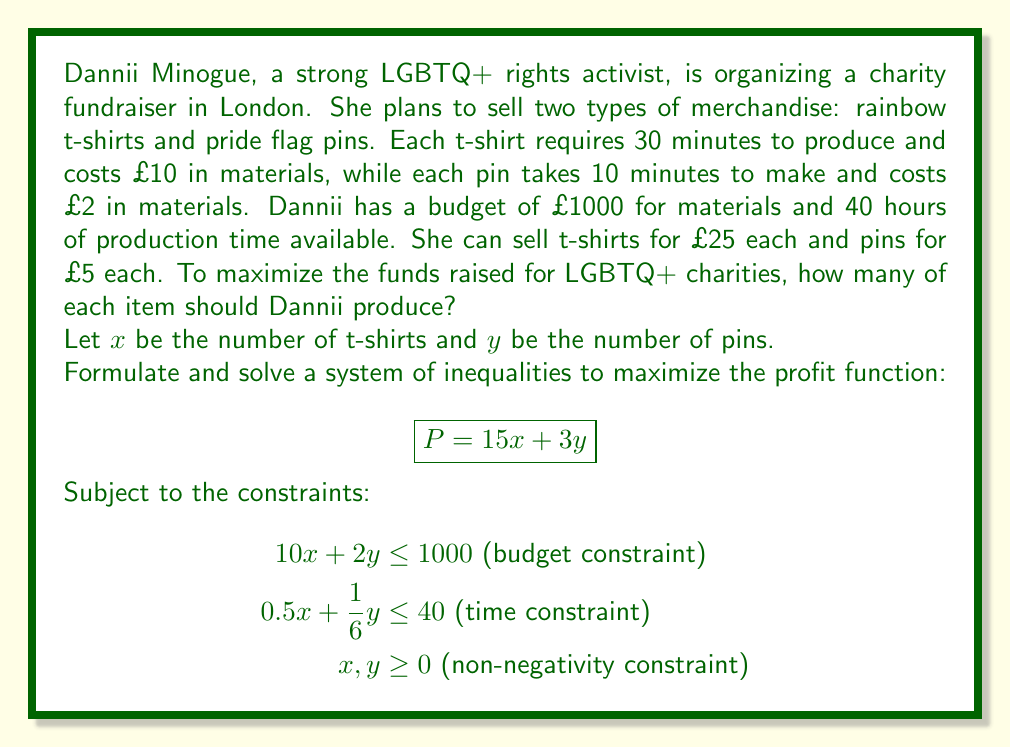Could you help me with this problem? To solve this problem, we'll follow these steps:

1) First, let's graph the constraints:

   Budget constraint: $10x + 2y = 1000$
   Time constraint: $0.5x + \frac{1}{6}y = 40$

   We can rewrite these in slope-intercept form:
   $$\begin{align}
   y &= 500 - 5x \text{ (budget)} \\
   y &= 240 - 3x \text{ (time)}
   \end{align}$$

2) We can plot these lines:

   [asy]
   import graph;
   size(200);
   xaxis("x", 0, 100);
   yaxis("y", 0, 300);
   draw((0,500)--(100,0), blue);
   draw((0,240)--(80,0), red);
   label("Budget", (50,250), blue);
   label("Time", (40,120), red);
   fill((0,0)--(0,240)--(80,0)--cycle, palegreen);
   dot((60,200));
   label("(60,200)", (62,202), E);
   [/asy]

3) The feasible region is the green shaded area. The optimal solution will be at one of the corner points of this region.

4) The corner points are (0,0), (0,240), (60,200), and (100,0).

5) Let's evaluate our profit function $P = 15x + 3y$ at each point:
   
   (0,0): $P = 0$
   (0,240): $P = 720$
   (60,200): $P = 1500$
   (100,0): $P = 1500$

6) The maximum profit occurs at (60,200), which means producing 60 t-shirts and 200 pins.

7) We can verify that this satisfies our constraints:
   
   Budget: $10(60) + 2(200) = 1000$
   Time: $0.5(60) + \frac{1}{6}(200) = 30 + \frac{100}{3} = 63.33$ hours, which is actually over our time limit.

8) Since we've exceeded our time constraint, we need to adjust our solution. We can solve the system of equations:

   $$\begin{align}
   10x + 2y &= 1000 \\
   0.5x + \frac{1}{6}y &= 40
   \end{align}$$

   Solving this system gives us $x = 80$ and $y = 100$.

9) Final check:
   
   Budget: $10(80) + 2(100) = 1000$
   Time: $0.5(80) + \frac{1}{6}(100) = 40 + \frac{50}{3} = 56.67$ hours, which is within our 40-hour limit.

   Profit: $P = 15(80) + 3(100) = 1200 + 300 = 1500$
Answer: Dannii should produce 80 t-shirts and 100 pins to maximize the funds raised for LGBTQ+ charities. This will result in a total profit of £1500. 